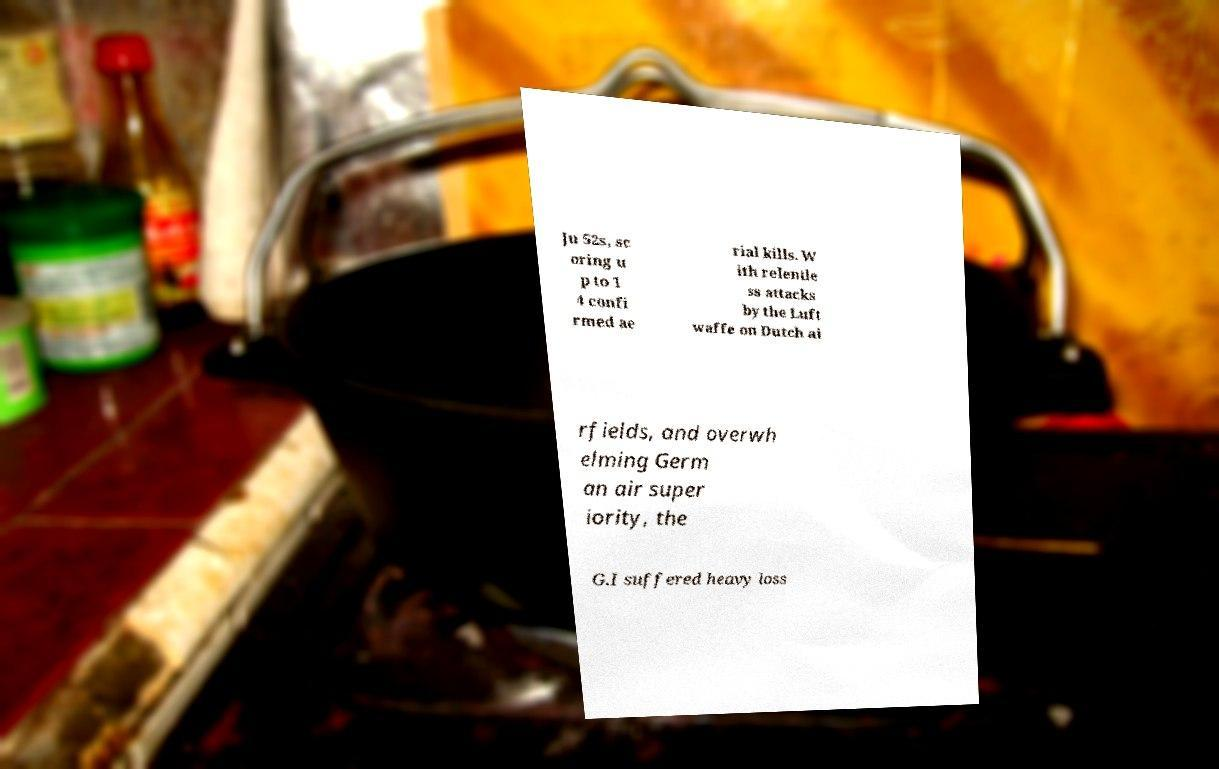Please read and relay the text visible in this image. What does it say? Ju 52s, sc oring u p to 1 4 confi rmed ae rial kills. W ith relentle ss attacks by the Luft waffe on Dutch ai rfields, and overwh elming Germ an air super iority, the G.I suffered heavy loss 